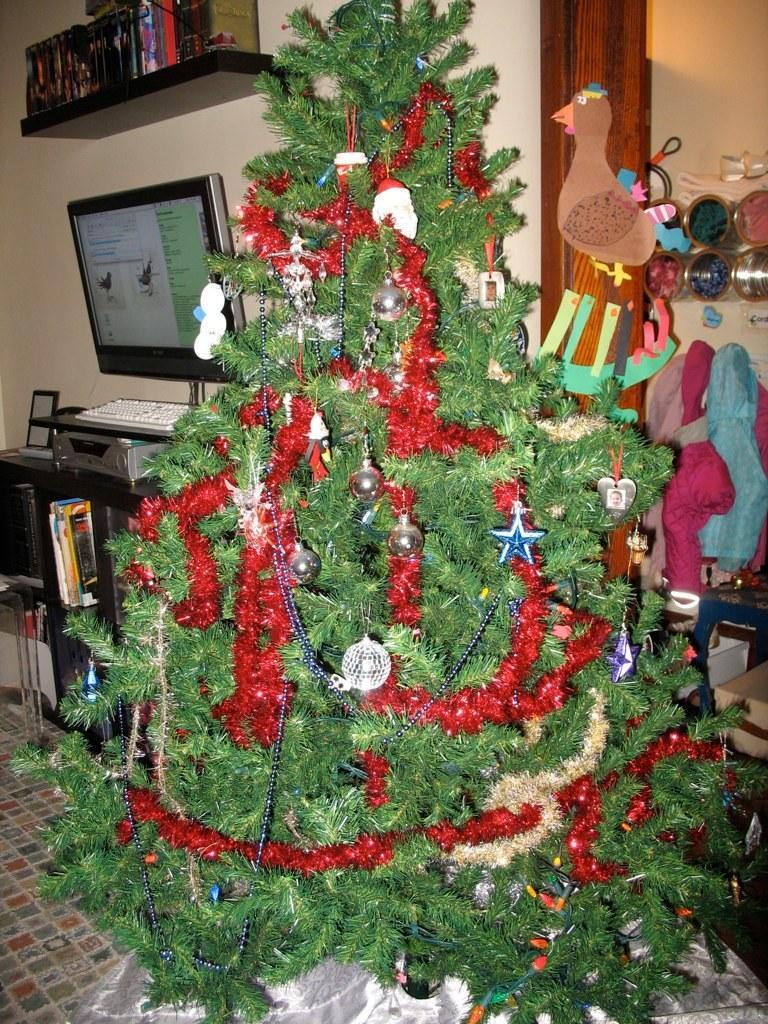Can you describe this image briefly? This is the picture of a room. In the foreground there is a Christmas tree and there are stars and balls on the tree. On the right side of the image there are objects. On the left side of the image there are books in the cupboard and there is a computer and keyboard on the table and there are books in the cupboard. 